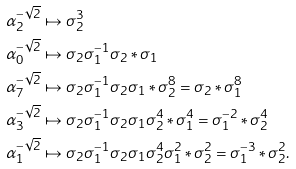Convert formula to latex. <formula><loc_0><loc_0><loc_500><loc_500>\alpha _ { 2 } ^ { - \sqrt { 2 } } & \mapsto \sigma _ { 2 } ^ { 3 } \\ \alpha _ { 0 } ^ { - \sqrt { 2 } } & \mapsto \sigma _ { 2 } \sigma _ { 1 } ^ { - 1 } \sigma _ { 2 } * \sigma _ { 1 } \\ \alpha _ { 7 } ^ { - \sqrt { 2 } } & \mapsto \sigma _ { 2 } \sigma _ { 1 } ^ { - 1 } \sigma _ { 2 } \sigma _ { 1 } * \sigma _ { 2 } ^ { 8 } = \sigma _ { 2 } * \sigma _ { 1 } ^ { 8 } \\ \alpha _ { 3 } ^ { - \sqrt { 2 } } & \mapsto \sigma _ { 2 } \sigma _ { 1 } ^ { - 1 } \sigma _ { 2 } \sigma _ { 1 } \sigma _ { 2 } ^ { 4 } * \sigma _ { 1 } ^ { 4 } = \sigma _ { 1 } ^ { - 2 } * \sigma _ { 2 } ^ { 4 } \\ \alpha _ { 1 } ^ { - \sqrt { 2 } } & \mapsto \sigma _ { 2 } \sigma _ { 1 } ^ { - 1 } \sigma _ { 2 } \sigma _ { 1 } \sigma _ { 2 } ^ { 4 } \sigma _ { 1 } ^ { 2 } * \sigma _ { 2 } ^ { 2 } = \sigma _ { 1 } ^ { - 3 } * \sigma _ { 2 } ^ { 2 } .</formula> 